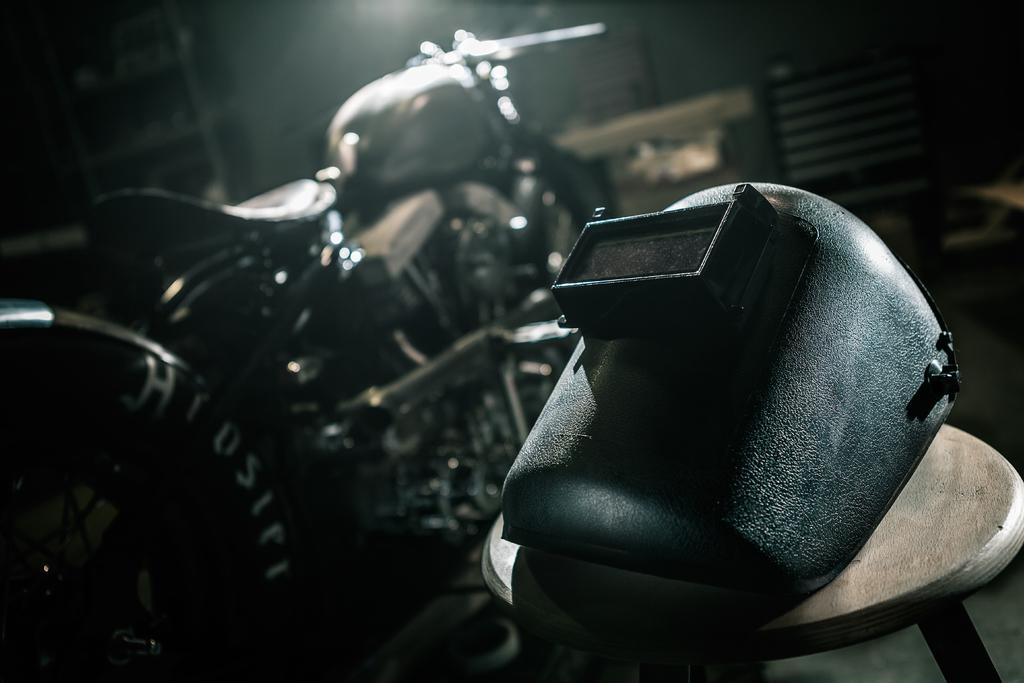What object is located on the right side of the image? There is a mask on the right side of the image. What vehicle is on the left side of the image? There is a motorcycle on the left side of the image. What type of breakfast is being served in the image? There is no breakfast present in the image; it only features a mask and a motorcycle. What religious symbol can be seen in the image? There is no religious symbol present in the image. 